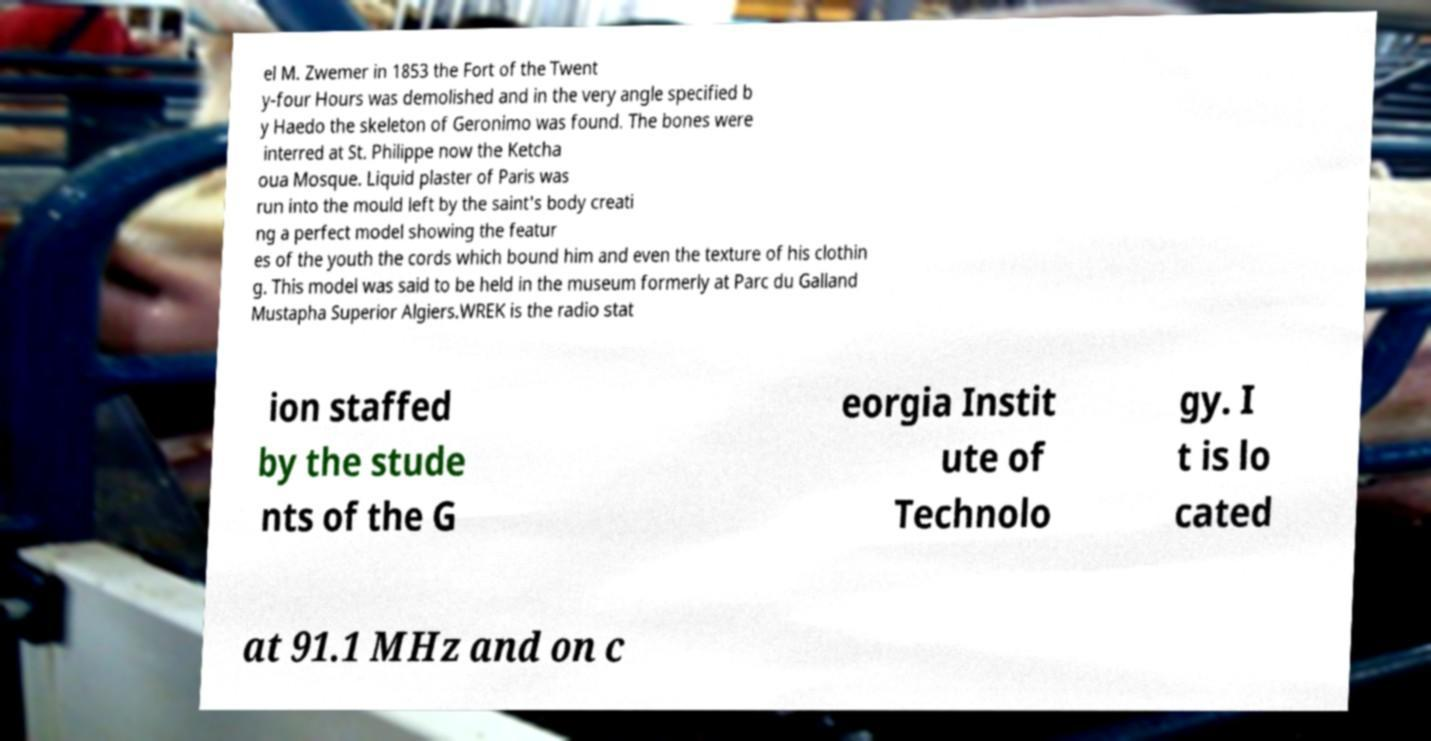Please identify and transcribe the text found in this image. el M. Zwemer in 1853 the Fort of the Twent y-four Hours was demolished and in the very angle specified b y Haedo the skeleton of Geronimo was found. The bones were interred at St. Philippe now the Ketcha oua Mosque. Liquid plaster of Paris was run into the mould left by the saint's body creati ng a perfect model showing the featur es of the youth the cords which bound him and even the texture of his clothin g. This model was said to be held in the museum formerly at Parc du Galland Mustapha Superior Algiers.WREK is the radio stat ion staffed by the stude nts of the G eorgia Instit ute of Technolo gy. I t is lo cated at 91.1 MHz and on c 